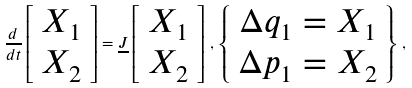<formula> <loc_0><loc_0><loc_500><loc_500>\frac { d } { d t } \left [ \begin{array} { c } X _ { 1 } \\ X _ { 2 } \end{array} \right ] = \underline { J } \left [ \begin{array} { c } X _ { 1 } \\ X _ { 2 } \end{array} \right ] \, , \, \left \{ \begin{array} { c } \Delta q _ { 1 } = X _ { 1 } \\ \Delta p _ { 1 } = X _ { 2 } \end{array} \right \} \, ,</formula> 